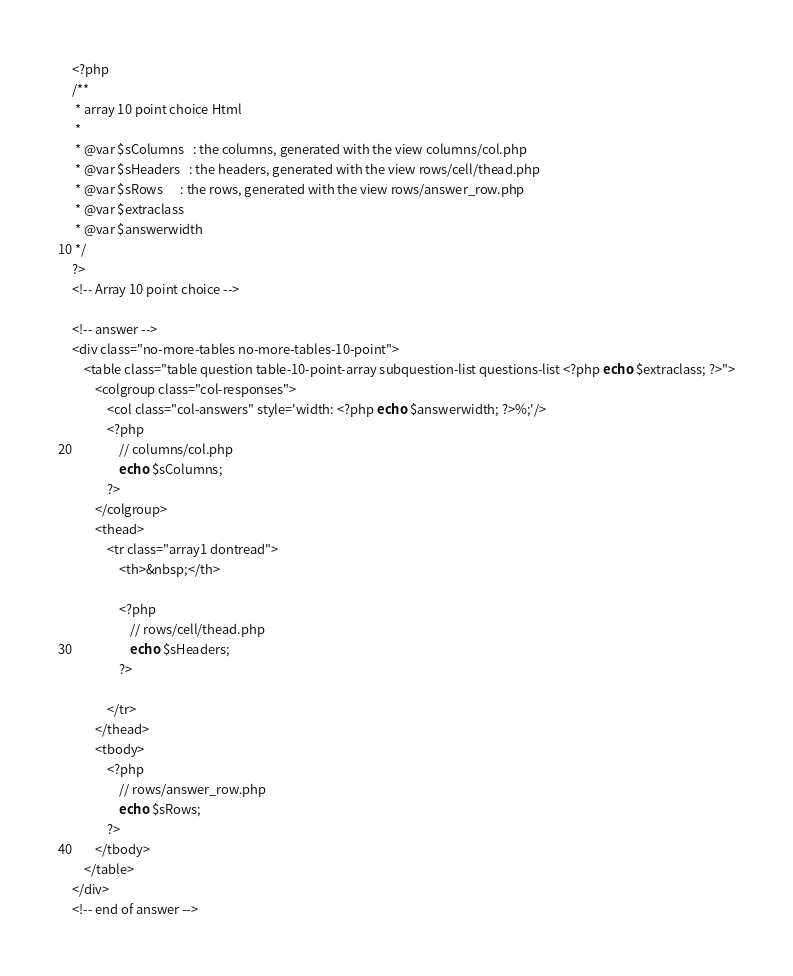Convert code to text. <code><loc_0><loc_0><loc_500><loc_500><_PHP_><?php
/**
 * array 10 point choice Html
 *
 * @var $sColumns   : the columns, generated with the view columns/col.php
 * @var $sHeaders   : the headers, generated with the view rows/cell/thead.php
 * @var $sRows      : the rows, generated with the view rows/answer_row.php
 * @var $extraclass
 * @var $answerwidth
 */
?>
<!-- Array 10 point choice -->

<!-- answer -->
<div class="no-more-tables no-more-tables-10-point">
    <table class="table question table-10-point-array subquestion-list questions-list <?php echo $extraclass; ?>">
        <colgroup class="col-responses">
            <col class="col-answers" style='width: <?php echo $answerwidth; ?>%;'/>
            <?php
                // columns/col.php
                echo $sColumns;
            ?>
        </colgroup>
        <thead>
            <tr class="array1 dontread">
                <th>&nbsp;</th>

                <?php
                    // rows/cell/thead.php
                    echo $sHeaders;
                ?>

            </tr>
        </thead>
        <tbody>
            <?php
                // rows/answer_row.php
                echo $sRows;
            ?>
        </tbody>
    </table>
</div>
<!-- end of answer -->
</code> 